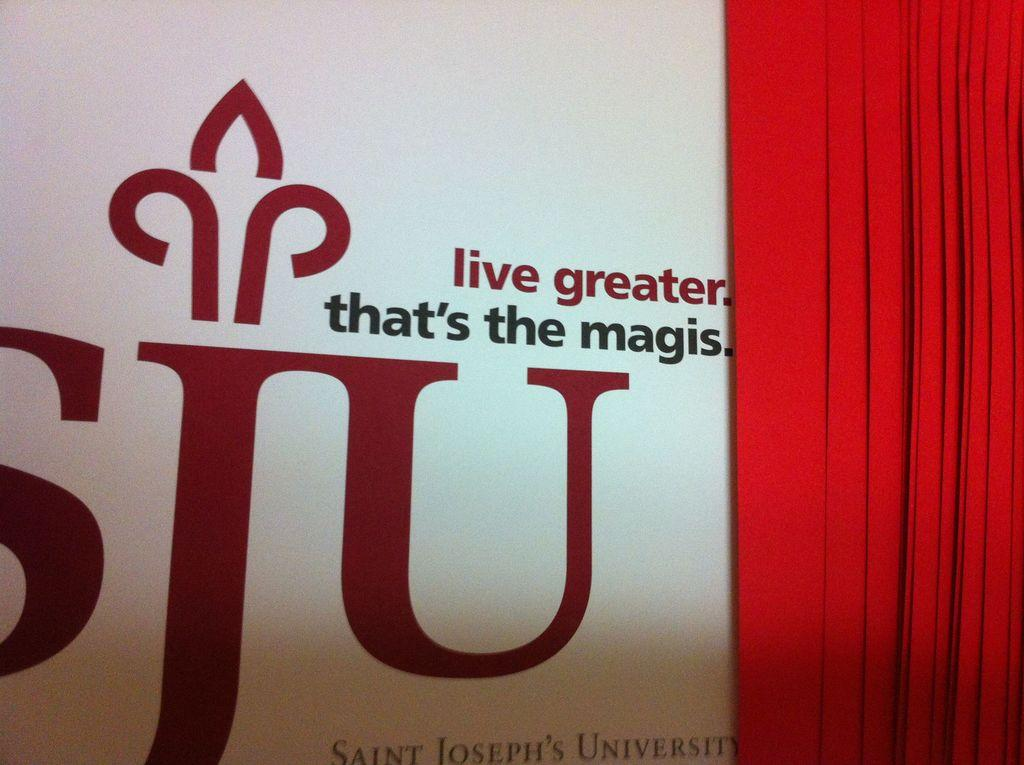<image>
Relay a brief, clear account of the picture shown. A large sign for Saint Joseph's University is standing behind a red curtain. 